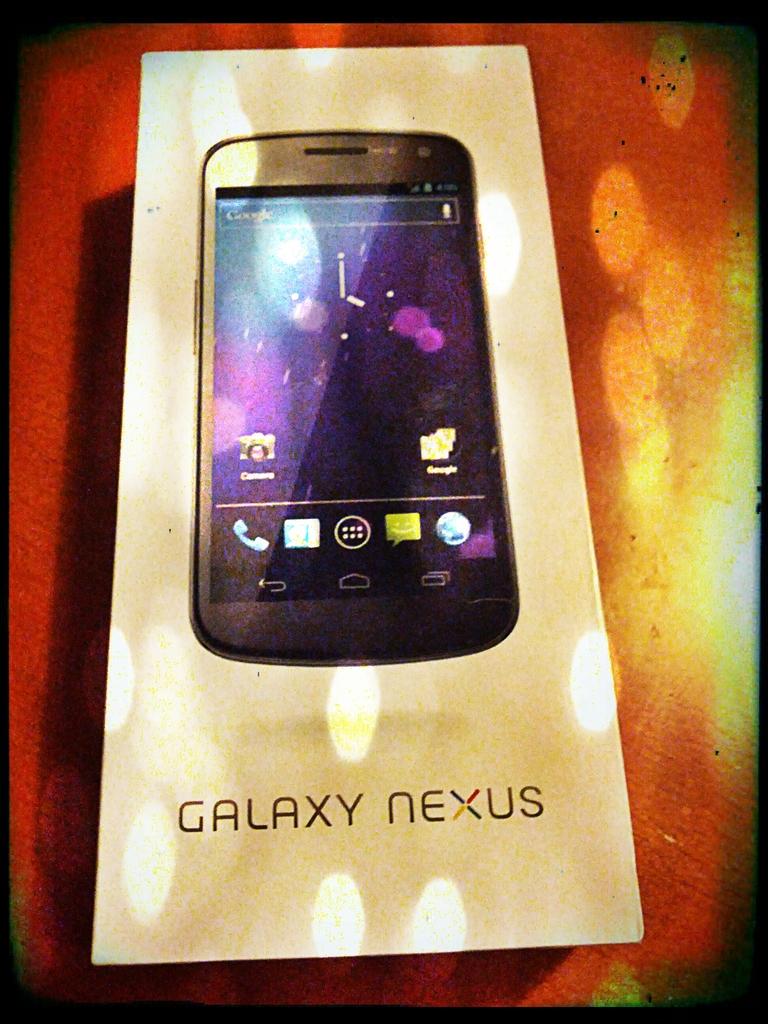What kind of phone is this?
Give a very brief answer. Galaxy nexus. Which model of galaxy is this?
Provide a succinct answer. Nexus. 